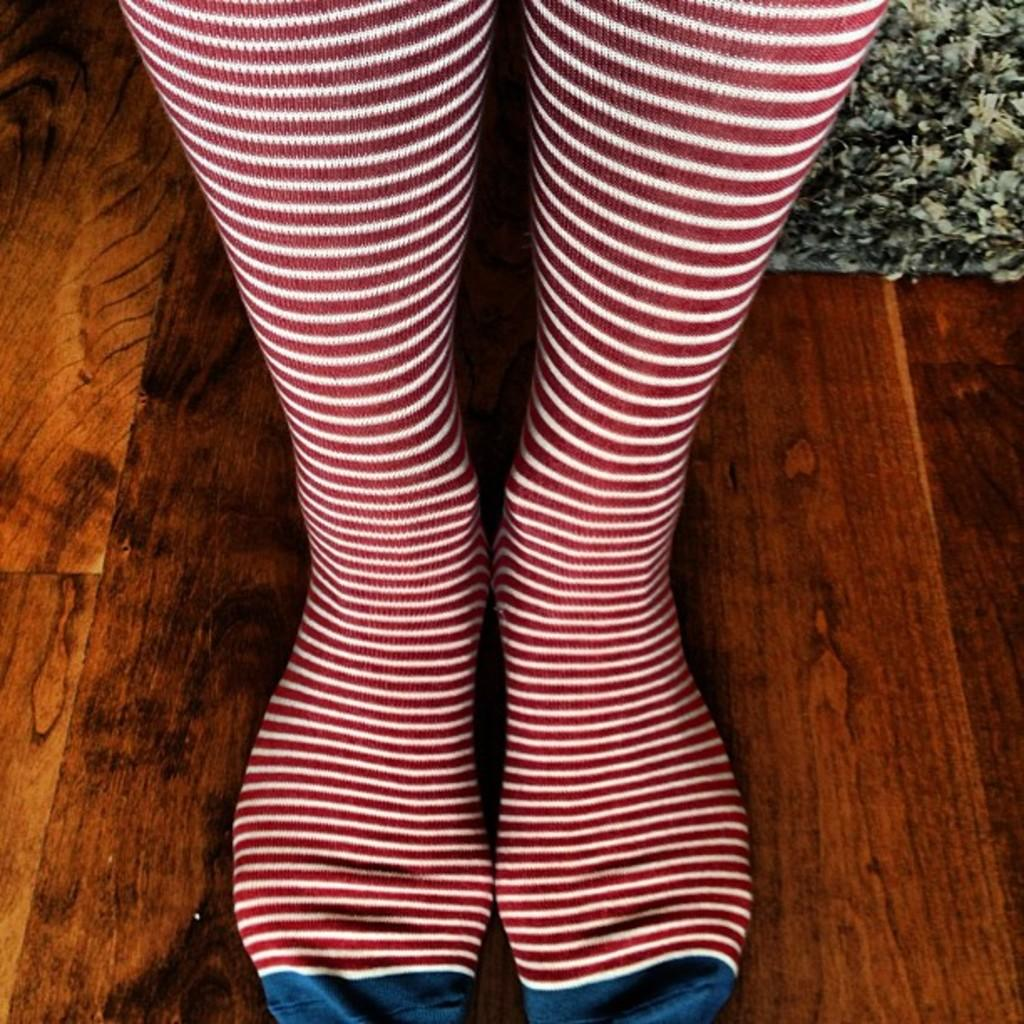What part of a person can be seen in the image? There are legs of a person visible in the image. What type of surface are the legs resting on? The legs are on a wooden surface. Can you describe the object in the top right corner of the image? Unfortunately, the facts provided do not give any information about the object in the top right corner. What type of beast is sleeping on the shelf in the image? There is no beast or shelf present in the image. 